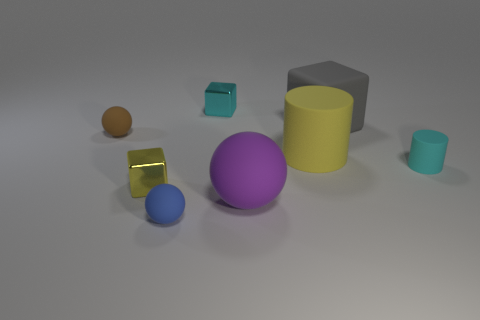What time of day does this setting suggest? The setting doesn't clearly indicate a time of day as the lighting seems artificial, hinting at a controlled environment where time isn't a factor, such as an indoor studio setting. Could you guess the purpose of arranging these objects like this? This arrangement of objects might serve several purposes, but it most likely is a composition for a visual study, perhaps related to color, form, or shading in a 3D modeling and rendering context. 